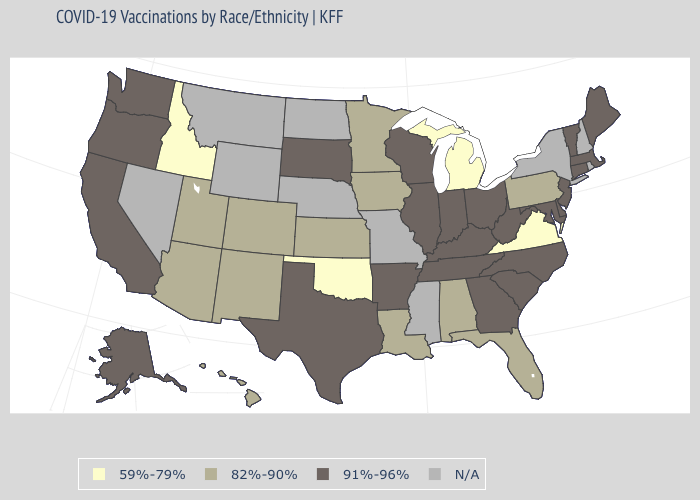Does Idaho have the lowest value in the West?
Keep it brief. Yes. Which states have the lowest value in the USA?
Concise answer only. Idaho, Michigan, Oklahoma, Virginia. Is the legend a continuous bar?
Be succinct. No. Which states hav the highest value in the Northeast?
Write a very short answer. Connecticut, Maine, Massachusetts, New Jersey, Vermont. What is the highest value in the MidWest ?
Short answer required. 91%-96%. What is the value of Georgia?
Keep it brief. 91%-96%. Name the states that have a value in the range 59%-79%?
Write a very short answer. Idaho, Michigan, Oklahoma, Virginia. Name the states that have a value in the range 59%-79%?
Be succinct. Idaho, Michigan, Oklahoma, Virginia. What is the value of North Dakota?
Concise answer only. N/A. Name the states that have a value in the range 82%-90%?
Give a very brief answer. Alabama, Arizona, Colorado, Florida, Hawaii, Iowa, Kansas, Louisiana, Minnesota, New Mexico, Pennsylvania, Utah. Among the states that border Indiana , does Kentucky have the highest value?
Answer briefly. Yes. What is the value of Arkansas?
Short answer required. 91%-96%. What is the highest value in the West ?
Give a very brief answer. 91%-96%. Name the states that have a value in the range 82%-90%?
Keep it brief. Alabama, Arizona, Colorado, Florida, Hawaii, Iowa, Kansas, Louisiana, Minnesota, New Mexico, Pennsylvania, Utah. 